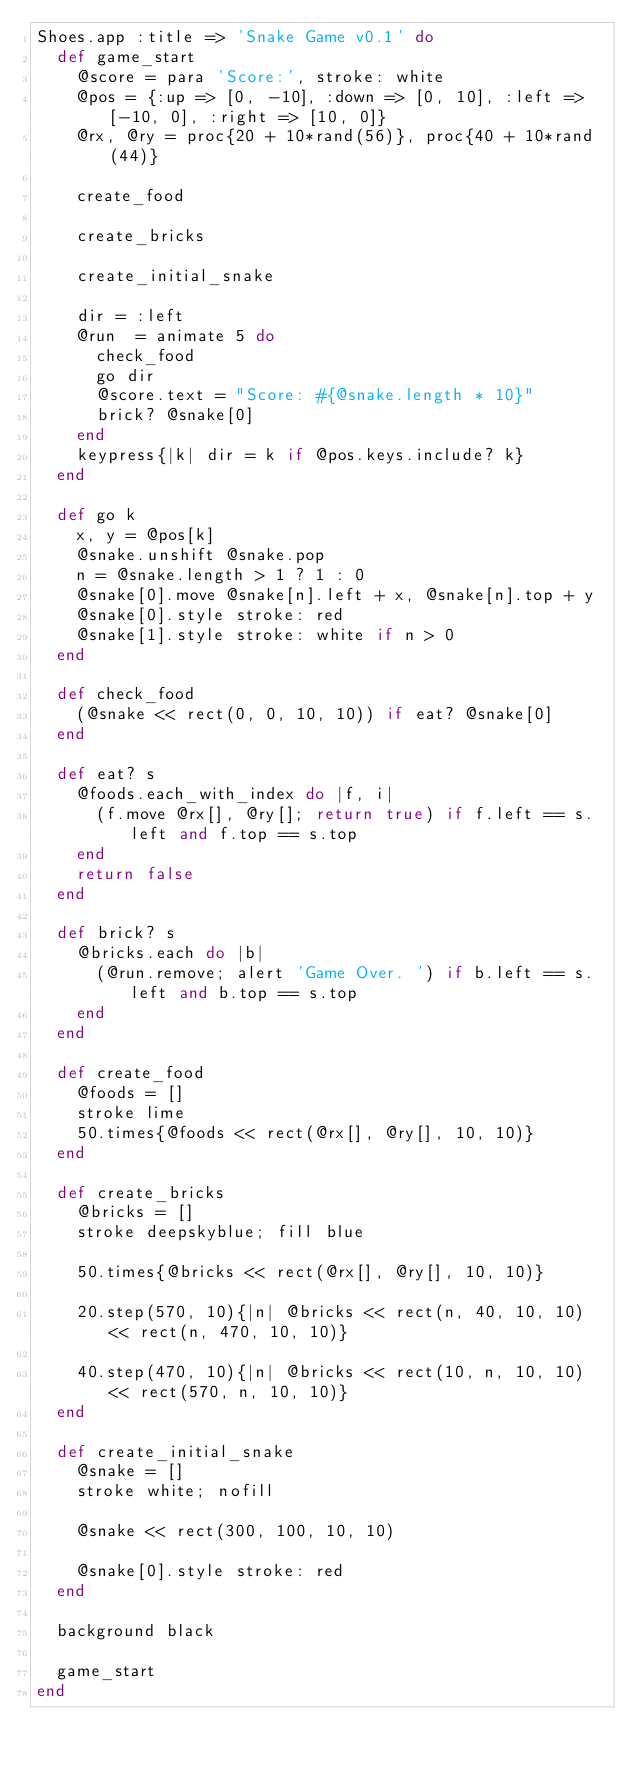<code> <loc_0><loc_0><loc_500><loc_500><_Ruby_>Shoes.app :title => 'Snake Game v0.1' do
  def game_start
    @score = para 'Score:', stroke: white
    @pos = {:up => [0, -10], :down => [0, 10], :left => [-10, 0], :right => [10, 0]}
    @rx, @ry = proc{20 + 10*rand(56)}, proc{40 + 10*rand(44)}

    create_food

    create_bricks

    create_initial_snake

    dir = :left
    @run  = animate 5 do
      check_food
      go dir
      @score.text = "Score: #{@snake.length * 10}"
      brick? @snake[0]
    end
    keypress{|k| dir = k if @pos.keys.include? k}
  end

  def go k
    x, y = @pos[k]
    @snake.unshift @snake.pop
    n = @snake.length > 1 ? 1 : 0
    @snake[0].move @snake[n].left + x, @snake[n].top + y
    @snake[0].style stroke: red
    @snake[1].style stroke: white if n > 0
  end

  def check_food
    (@snake << rect(0, 0, 10, 10)) if eat? @snake[0]
  end

  def eat? s
    @foods.each_with_index do |f, i|
      (f.move @rx[], @ry[]; return true) if f.left == s.left and f.top == s.top
    end
    return false
  end

  def brick? s
    @bricks.each do |b|
      (@run.remove; alert 'Game Over. ') if b.left == s.left and b.top == s.top      
    end
  end

  def create_food
    @foods = []
    stroke lime
    50.times{@foods << rect(@rx[], @ry[], 10, 10)}
  end

  def create_bricks
    @bricks = []
    stroke deepskyblue; fill blue

    50.times{@bricks << rect(@rx[], @ry[], 10, 10)}

    20.step(570, 10){|n| @bricks << rect(n, 40, 10, 10) << rect(n, 470, 10, 10)}

    40.step(470, 10){|n| @bricks << rect(10, n, 10, 10) << rect(570, n, 10, 10)}
  end

  def create_initial_snake
    @snake = []
    stroke white; nofill

    @snake << rect(300, 100, 10, 10)

    @snake[0].style stroke: red
  end

  background black

  game_start
end
</code> 